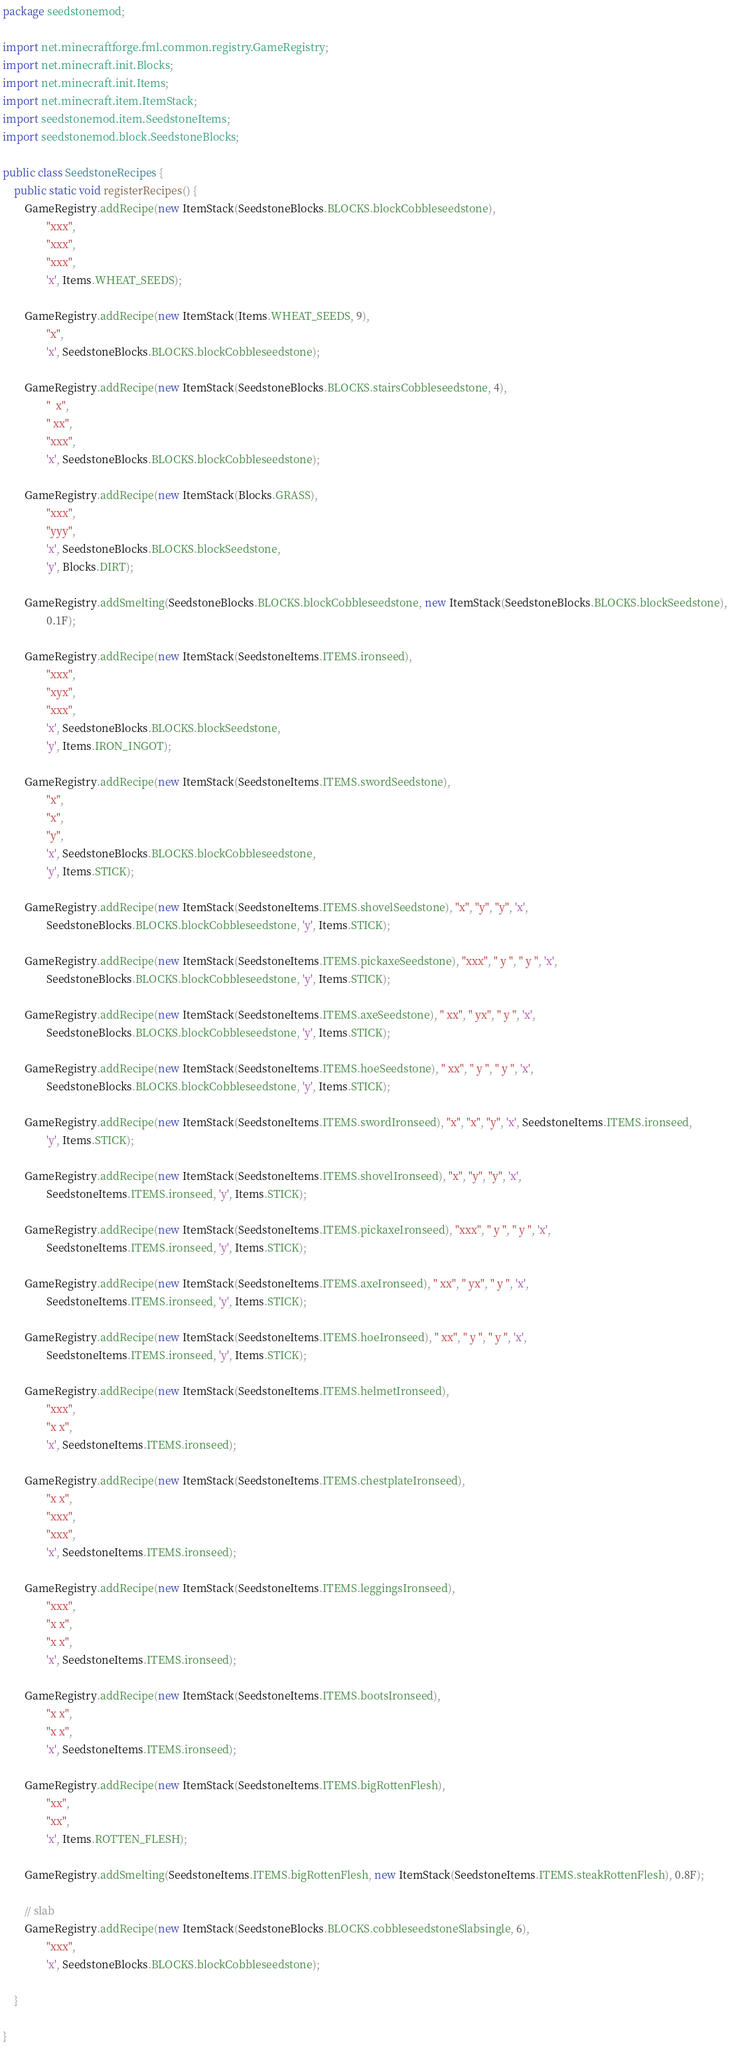<code> <loc_0><loc_0><loc_500><loc_500><_Java_>package seedstonemod;

import net.minecraftforge.fml.common.registry.GameRegistry;
import net.minecraft.init.Blocks;
import net.minecraft.init.Items;
import net.minecraft.item.ItemStack;
import seedstonemod.item.SeedstoneItems;
import seedstonemod.block.SeedstoneBlocks;

public class SeedstoneRecipes {
    public static void registerRecipes() {
        GameRegistry.addRecipe(new ItemStack(SeedstoneBlocks.BLOCKS.blockCobbleseedstone),
                "xxx",
                "xxx",
                "xxx",
                'x', Items.WHEAT_SEEDS);

        GameRegistry.addRecipe(new ItemStack(Items.WHEAT_SEEDS, 9),
                "x",
                'x', SeedstoneBlocks.BLOCKS.blockCobbleseedstone);

        GameRegistry.addRecipe(new ItemStack(SeedstoneBlocks.BLOCKS.stairsCobbleseedstone, 4),
                "  x",
                " xx",
                "xxx",
                'x', SeedstoneBlocks.BLOCKS.blockCobbleseedstone);

        GameRegistry.addRecipe(new ItemStack(Blocks.GRASS),
                "xxx",
                "yyy",
                'x', SeedstoneBlocks.BLOCKS.blockSeedstone,
                'y', Blocks.DIRT);

        GameRegistry.addSmelting(SeedstoneBlocks.BLOCKS.blockCobbleseedstone, new ItemStack(SeedstoneBlocks.BLOCKS.blockSeedstone),
                0.1F);

        GameRegistry.addRecipe(new ItemStack(SeedstoneItems.ITEMS.ironseed),
                "xxx",
                "xyx",
                "xxx",
                'x', SeedstoneBlocks.BLOCKS.blockSeedstone,
                'y', Items.IRON_INGOT);

        GameRegistry.addRecipe(new ItemStack(SeedstoneItems.ITEMS.swordSeedstone),
                "x",
                "x",
                "y",
                'x', SeedstoneBlocks.BLOCKS.blockCobbleseedstone,
                'y', Items.STICK);

        GameRegistry.addRecipe(new ItemStack(SeedstoneItems.ITEMS.shovelSeedstone), "x", "y", "y", 'x',
                SeedstoneBlocks.BLOCKS.blockCobbleseedstone, 'y', Items.STICK);

        GameRegistry.addRecipe(new ItemStack(SeedstoneItems.ITEMS.pickaxeSeedstone), "xxx", " y ", " y ", 'x',
                SeedstoneBlocks.BLOCKS.blockCobbleseedstone, 'y', Items.STICK);

        GameRegistry.addRecipe(new ItemStack(SeedstoneItems.ITEMS.axeSeedstone), " xx", " yx", " y ", 'x',
                SeedstoneBlocks.BLOCKS.blockCobbleseedstone, 'y', Items.STICK);

        GameRegistry.addRecipe(new ItemStack(SeedstoneItems.ITEMS.hoeSeedstone), " xx", " y ", " y ", 'x',
                SeedstoneBlocks.BLOCKS.blockCobbleseedstone, 'y', Items.STICK);

        GameRegistry.addRecipe(new ItemStack(SeedstoneItems.ITEMS.swordIronseed), "x", "x", "y", 'x', SeedstoneItems.ITEMS.ironseed,
                'y', Items.STICK);

        GameRegistry.addRecipe(new ItemStack(SeedstoneItems.ITEMS.shovelIronseed), "x", "y", "y", 'x',
                SeedstoneItems.ITEMS.ironseed, 'y', Items.STICK);

        GameRegistry.addRecipe(new ItemStack(SeedstoneItems.ITEMS.pickaxeIronseed), "xxx", " y ", " y ", 'x',
                SeedstoneItems.ITEMS.ironseed, 'y', Items.STICK);

        GameRegistry.addRecipe(new ItemStack(SeedstoneItems.ITEMS.axeIronseed), " xx", " yx", " y ", 'x',
                SeedstoneItems.ITEMS.ironseed, 'y', Items.STICK);

        GameRegistry.addRecipe(new ItemStack(SeedstoneItems.ITEMS.hoeIronseed), " xx", " y ", " y ", 'x',
                SeedstoneItems.ITEMS.ironseed, 'y', Items.STICK);

        GameRegistry.addRecipe(new ItemStack(SeedstoneItems.ITEMS.helmetIronseed),
                "xxx",
                "x x",
                'x', SeedstoneItems.ITEMS.ironseed);

        GameRegistry.addRecipe(new ItemStack(SeedstoneItems.ITEMS.chestplateIronseed),
                "x x",
                "xxx",
                "xxx",
                'x', SeedstoneItems.ITEMS.ironseed);

        GameRegistry.addRecipe(new ItemStack(SeedstoneItems.ITEMS.leggingsIronseed),
                "xxx",
                "x x",
                "x x",
                'x', SeedstoneItems.ITEMS.ironseed);

        GameRegistry.addRecipe(new ItemStack(SeedstoneItems.ITEMS.bootsIronseed),
                "x x",
                "x x",
                'x', SeedstoneItems.ITEMS.ironseed);

        GameRegistry.addRecipe(new ItemStack(SeedstoneItems.ITEMS.bigRottenFlesh),
                "xx",
                "xx",
                'x', Items.ROTTEN_FLESH);

        GameRegistry.addSmelting(SeedstoneItems.ITEMS.bigRottenFlesh, new ItemStack(SeedstoneItems.ITEMS.steakRottenFlesh), 0.8F);

        // slab
        GameRegistry.addRecipe(new ItemStack(SeedstoneBlocks.BLOCKS.cobbleseedstoneSlabsingle, 6),
                "xxx",
                'x', SeedstoneBlocks.BLOCKS.blockCobbleseedstone);

    }

}
</code> 